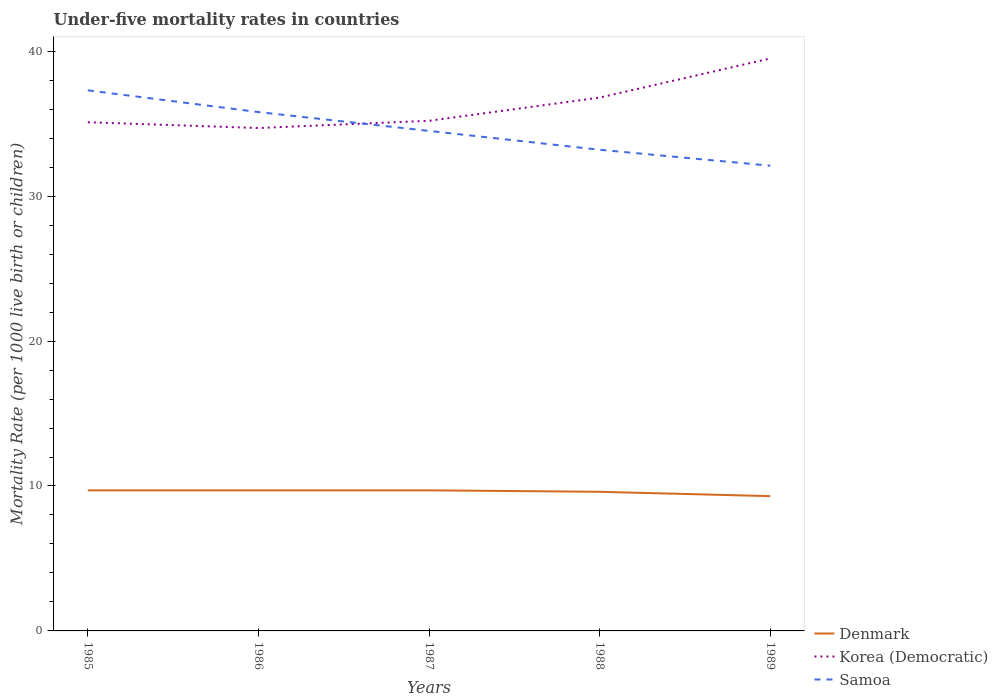Is the number of lines equal to the number of legend labels?
Your answer should be very brief. Yes. Across all years, what is the maximum under-five mortality rate in Samoa?
Offer a very short reply. 32.1. What is the difference between the highest and the second highest under-five mortality rate in Korea (Democratic)?
Make the answer very short. 4.8. How many lines are there?
Provide a succinct answer. 3. How many years are there in the graph?
Provide a short and direct response. 5. What is the difference between two consecutive major ticks on the Y-axis?
Your answer should be compact. 10. Are the values on the major ticks of Y-axis written in scientific E-notation?
Offer a very short reply. No. Does the graph contain grids?
Provide a succinct answer. No. Where does the legend appear in the graph?
Make the answer very short. Bottom right. How many legend labels are there?
Offer a very short reply. 3. What is the title of the graph?
Offer a terse response. Under-five mortality rates in countries. Does "World" appear as one of the legend labels in the graph?
Your answer should be compact. No. What is the label or title of the X-axis?
Offer a very short reply. Years. What is the label or title of the Y-axis?
Offer a very short reply. Mortality Rate (per 1000 live birth or children). What is the Mortality Rate (per 1000 live birth or children) in Denmark in 1985?
Your answer should be compact. 9.7. What is the Mortality Rate (per 1000 live birth or children) in Korea (Democratic) in 1985?
Ensure brevity in your answer.  35.1. What is the Mortality Rate (per 1000 live birth or children) in Samoa in 1985?
Give a very brief answer. 37.3. What is the Mortality Rate (per 1000 live birth or children) of Denmark in 1986?
Offer a terse response. 9.7. What is the Mortality Rate (per 1000 live birth or children) in Korea (Democratic) in 1986?
Ensure brevity in your answer.  34.7. What is the Mortality Rate (per 1000 live birth or children) in Samoa in 1986?
Make the answer very short. 35.8. What is the Mortality Rate (per 1000 live birth or children) in Denmark in 1987?
Give a very brief answer. 9.7. What is the Mortality Rate (per 1000 live birth or children) of Korea (Democratic) in 1987?
Your answer should be compact. 35.2. What is the Mortality Rate (per 1000 live birth or children) in Samoa in 1987?
Your answer should be very brief. 34.5. What is the Mortality Rate (per 1000 live birth or children) in Korea (Democratic) in 1988?
Offer a terse response. 36.8. What is the Mortality Rate (per 1000 live birth or children) of Samoa in 1988?
Keep it short and to the point. 33.2. What is the Mortality Rate (per 1000 live birth or children) in Denmark in 1989?
Your answer should be compact. 9.3. What is the Mortality Rate (per 1000 live birth or children) of Korea (Democratic) in 1989?
Keep it short and to the point. 39.5. What is the Mortality Rate (per 1000 live birth or children) in Samoa in 1989?
Your answer should be very brief. 32.1. Across all years, what is the maximum Mortality Rate (per 1000 live birth or children) in Denmark?
Ensure brevity in your answer.  9.7. Across all years, what is the maximum Mortality Rate (per 1000 live birth or children) in Korea (Democratic)?
Ensure brevity in your answer.  39.5. Across all years, what is the maximum Mortality Rate (per 1000 live birth or children) in Samoa?
Provide a succinct answer. 37.3. Across all years, what is the minimum Mortality Rate (per 1000 live birth or children) of Denmark?
Make the answer very short. 9.3. Across all years, what is the minimum Mortality Rate (per 1000 live birth or children) in Korea (Democratic)?
Provide a short and direct response. 34.7. Across all years, what is the minimum Mortality Rate (per 1000 live birth or children) in Samoa?
Your answer should be very brief. 32.1. What is the total Mortality Rate (per 1000 live birth or children) of Korea (Democratic) in the graph?
Ensure brevity in your answer.  181.3. What is the total Mortality Rate (per 1000 live birth or children) in Samoa in the graph?
Your answer should be compact. 172.9. What is the difference between the Mortality Rate (per 1000 live birth or children) in Samoa in 1985 and that in 1986?
Offer a very short reply. 1.5. What is the difference between the Mortality Rate (per 1000 live birth or children) in Korea (Democratic) in 1985 and that in 1987?
Keep it short and to the point. -0.1. What is the difference between the Mortality Rate (per 1000 live birth or children) of Samoa in 1985 and that in 1987?
Your answer should be very brief. 2.8. What is the difference between the Mortality Rate (per 1000 live birth or children) of Denmark in 1985 and that in 1988?
Keep it short and to the point. 0.1. What is the difference between the Mortality Rate (per 1000 live birth or children) of Korea (Democratic) in 1985 and that in 1988?
Make the answer very short. -1.7. What is the difference between the Mortality Rate (per 1000 live birth or children) of Korea (Democratic) in 1985 and that in 1989?
Keep it short and to the point. -4.4. What is the difference between the Mortality Rate (per 1000 live birth or children) in Denmark in 1986 and that in 1987?
Give a very brief answer. 0. What is the difference between the Mortality Rate (per 1000 live birth or children) of Samoa in 1986 and that in 1987?
Offer a terse response. 1.3. What is the difference between the Mortality Rate (per 1000 live birth or children) of Denmark in 1986 and that in 1988?
Your answer should be very brief. 0.1. What is the difference between the Mortality Rate (per 1000 live birth or children) of Korea (Democratic) in 1986 and that in 1988?
Provide a short and direct response. -2.1. What is the difference between the Mortality Rate (per 1000 live birth or children) in Denmark in 1986 and that in 1989?
Your answer should be very brief. 0.4. What is the difference between the Mortality Rate (per 1000 live birth or children) of Korea (Democratic) in 1986 and that in 1989?
Provide a succinct answer. -4.8. What is the difference between the Mortality Rate (per 1000 live birth or children) in Samoa in 1986 and that in 1989?
Your answer should be very brief. 3.7. What is the difference between the Mortality Rate (per 1000 live birth or children) in Denmark in 1987 and that in 1988?
Offer a very short reply. 0.1. What is the difference between the Mortality Rate (per 1000 live birth or children) in Samoa in 1987 and that in 1988?
Make the answer very short. 1.3. What is the difference between the Mortality Rate (per 1000 live birth or children) in Korea (Democratic) in 1987 and that in 1989?
Keep it short and to the point. -4.3. What is the difference between the Mortality Rate (per 1000 live birth or children) of Denmark in 1988 and that in 1989?
Offer a very short reply. 0.3. What is the difference between the Mortality Rate (per 1000 live birth or children) of Korea (Democratic) in 1988 and that in 1989?
Keep it short and to the point. -2.7. What is the difference between the Mortality Rate (per 1000 live birth or children) in Denmark in 1985 and the Mortality Rate (per 1000 live birth or children) in Samoa in 1986?
Your answer should be compact. -26.1. What is the difference between the Mortality Rate (per 1000 live birth or children) in Korea (Democratic) in 1985 and the Mortality Rate (per 1000 live birth or children) in Samoa in 1986?
Your answer should be compact. -0.7. What is the difference between the Mortality Rate (per 1000 live birth or children) in Denmark in 1985 and the Mortality Rate (per 1000 live birth or children) in Korea (Democratic) in 1987?
Offer a terse response. -25.5. What is the difference between the Mortality Rate (per 1000 live birth or children) of Denmark in 1985 and the Mortality Rate (per 1000 live birth or children) of Samoa in 1987?
Provide a short and direct response. -24.8. What is the difference between the Mortality Rate (per 1000 live birth or children) of Denmark in 1985 and the Mortality Rate (per 1000 live birth or children) of Korea (Democratic) in 1988?
Ensure brevity in your answer.  -27.1. What is the difference between the Mortality Rate (per 1000 live birth or children) in Denmark in 1985 and the Mortality Rate (per 1000 live birth or children) in Samoa in 1988?
Offer a terse response. -23.5. What is the difference between the Mortality Rate (per 1000 live birth or children) of Korea (Democratic) in 1985 and the Mortality Rate (per 1000 live birth or children) of Samoa in 1988?
Your answer should be compact. 1.9. What is the difference between the Mortality Rate (per 1000 live birth or children) of Denmark in 1985 and the Mortality Rate (per 1000 live birth or children) of Korea (Democratic) in 1989?
Provide a succinct answer. -29.8. What is the difference between the Mortality Rate (per 1000 live birth or children) in Denmark in 1985 and the Mortality Rate (per 1000 live birth or children) in Samoa in 1989?
Make the answer very short. -22.4. What is the difference between the Mortality Rate (per 1000 live birth or children) in Korea (Democratic) in 1985 and the Mortality Rate (per 1000 live birth or children) in Samoa in 1989?
Your response must be concise. 3. What is the difference between the Mortality Rate (per 1000 live birth or children) in Denmark in 1986 and the Mortality Rate (per 1000 live birth or children) in Korea (Democratic) in 1987?
Provide a short and direct response. -25.5. What is the difference between the Mortality Rate (per 1000 live birth or children) of Denmark in 1986 and the Mortality Rate (per 1000 live birth or children) of Samoa in 1987?
Offer a very short reply. -24.8. What is the difference between the Mortality Rate (per 1000 live birth or children) of Korea (Democratic) in 1986 and the Mortality Rate (per 1000 live birth or children) of Samoa in 1987?
Keep it short and to the point. 0.2. What is the difference between the Mortality Rate (per 1000 live birth or children) in Denmark in 1986 and the Mortality Rate (per 1000 live birth or children) in Korea (Democratic) in 1988?
Your answer should be very brief. -27.1. What is the difference between the Mortality Rate (per 1000 live birth or children) in Denmark in 1986 and the Mortality Rate (per 1000 live birth or children) in Samoa in 1988?
Ensure brevity in your answer.  -23.5. What is the difference between the Mortality Rate (per 1000 live birth or children) in Denmark in 1986 and the Mortality Rate (per 1000 live birth or children) in Korea (Democratic) in 1989?
Your response must be concise. -29.8. What is the difference between the Mortality Rate (per 1000 live birth or children) in Denmark in 1986 and the Mortality Rate (per 1000 live birth or children) in Samoa in 1989?
Your answer should be compact. -22.4. What is the difference between the Mortality Rate (per 1000 live birth or children) of Denmark in 1987 and the Mortality Rate (per 1000 live birth or children) of Korea (Democratic) in 1988?
Your response must be concise. -27.1. What is the difference between the Mortality Rate (per 1000 live birth or children) of Denmark in 1987 and the Mortality Rate (per 1000 live birth or children) of Samoa in 1988?
Your answer should be compact. -23.5. What is the difference between the Mortality Rate (per 1000 live birth or children) in Korea (Democratic) in 1987 and the Mortality Rate (per 1000 live birth or children) in Samoa in 1988?
Give a very brief answer. 2. What is the difference between the Mortality Rate (per 1000 live birth or children) in Denmark in 1987 and the Mortality Rate (per 1000 live birth or children) in Korea (Democratic) in 1989?
Keep it short and to the point. -29.8. What is the difference between the Mortality Rate (per 1000 live birth or children) of Denmark in 1987 and the Mortality Rate (per 1000 live birth or children) of Samoa in 1989?
Your response must be concise. -22.4. What is the difference between the Mortality Rate (per 1000 live birth or children) of Korea (Democratic) in 1987 and the Mortality Rate (per 1000 live birth or children) of Samoa in 1989?
Keep it short and to the point. 3.1. What is the difference between the Mortality Rate (per 1000 live birth or children) in Denmark in 1988 and the Mortality Rate (per 1000 live birth or children) in Korea (Democratic) in 1989?
Offer a terse response. -29.9. What is the difference between the Mortality Rate (per 1000 live birth or children) in Denmark in 1988 and the Mortality Rate (per 1000 live birth or children) in Samoa in 1989?
Keep it short and to the point. -22.5. What is the average Mortality Rate (per 1000 live birth or children) of Denmark per year?
Offer a very short reply. 9.6. What is the average Mortality Rate (per 1000 live birth or children) in Korea (Democratic) per year?
Keep it short and to the point. 36.26. What is the average Mortality Rate (per 1000 live birth or children) of Samoa per year?
Provide a short and direct response. 34.58. In the year 1985, what is the difference between the Mortality Rate (per 1000 live birth or children) in Denmark and Mortality Rate (per 1000 live birth or children) in Korea (Democratic)?
Give a very brief answer. -25.4. In the year 1985, what is the difference between the Mortality Rate (per 1000 live birth or children) of Denmark and Mortality Rate (per 1000 live birth or children) of Samoa?
Ensure brevity in your answer.  -27.6. In the year 1986, what is the difference between the Mortality Rate (per 1000 live birth or children) of Denmark and Mortality Rate (per 1000 live birth or children) of Korea (Democratic)?
Keep it short and to the point. -25. In the year 1986, what is the difference between the Mortality Rate (per 1000 live birth or children) in Denmark and Mortality Rate (per 1000 live birth or children) in Samoa?
Provide a short and direct response. -26.1. In the year 1986, what is the difference between the Mortality Rate (per 1000 live birth or children) of Korea (Democratic) and Mortality Rate (per 1000 live birth or children) of Samoa?
Give a very brief answer. -1.1. In the year 1987, what is the difference between the Mortality Rate (per 1000 live birth or children) of Denmark and Mortality Rate (per 1000 live birth or children) of Korea (Democratic)?
Make the answer very short. -25.5. In the year 1987, what is the difference between the Mortality Rate (per 1000 live birth or children) of Denmark and Mortality Rate (per 1000 live birth or children) of Samoa?
Offer a very short reply. -24.8. In the year 1987, what is the difference between the Mortality Rate (per 1000 live birth or children) in Korea (Democratic) and Mortality Rate (per 1000 live birth or children) in Samoa?
Offer a terse response. 0.7. In the year 1988, what is the difference between the Mortality Rate (per 1000 live birth or children) of Denmark and Mortality Rate (per 1000 live birth or children) of Korea (Democratic)?
Keep it short and to the point. -27.2. In the year 1988, what is the difference between the Mortality Rate (per 1000 live birth or children) in Denmark and Mortality Rate (per 1000 live birth or children) in Samoa?
Your answer should be very brief. -23.6. In the year 1989, what is the difference between the Mortality Rate (per 1000 live birth or children) in Denmark and Mortality Rate (per 1000 live birth or children) in Korea (Democratic)?
Ensure brevity in your answer.  -30.2. In the year 1989, what is the difference between the Mortality Rate (per 1000 live birth or children) in Denmark and Mortality Rate (per 1000 live birth or children) in Samoa?
Give a very brief answer. -22.8. What is the ratio of the Mortality Rate (per 1000 live birth or children) of Denmark in 1985 to that in 1986?
Make the answer very short. 1. What is the ratio of the Mortality Rate (per 1000 live birth or children) in Korea (Democratic) in 1985 to that in 1986?
Ensure brevity in your answer.  1.01. What is the ratio of the Mortality Rate (per 1000 live birth or children) of Samoa in 1985 to that in 1986?
Your answer should be very brief. 1.04. What is the ratio of the Mortality Rate (per 1000 live birth or children) of Denmark in 1985 to that in 1987?
Your answer should be very brief. 1. What is the ratio of the Mortality Rate (per 1000 live birth or children) in Korea (Democratic) in 1985 to that in 1987?
Your response must be concise. 1. What is the ratio of the Mortality Rate (per 1000 live birth or children) in Samoa in 1985 to that in 1987?
Give a very brief answer. 1.08. What is the ratio of the Mortality Rate (per 1000 live birth or children) in Denmark in 1985 to that in 1988?
Make the answer very short. 1.01. What is the ratio of the Mortality Rate (per 1000 live birth or children) in Korea (Democratic) in 1985 to that in 1988?
Offer a terse response. 0.95. What is the ratio of the Mortality Rate (per 1000 live birth or children) in Samoa in 1985 to that in 1988?
Keep it short and to the point. 1.12. What is the ratio of the Mortality Rate (per 1000 live birth or children) of Denmark in 1985 to that in 1989?
Provide a succinct answer. 1.04. What is the ratio of the Mortality Rate (per 1000 live birth or children) in Korea (Democratic) in 1985 to that in 1989?
Keep it short and to the point. 0.89. What is the ratio of the Mortality Rate (per 1000 live birth or children) of Samoa in 1985 to that in 1989?
Provide a short and direct response. 1.16. What is the ratio of the Mortality Rate (per 1000 live birth or children) of Denmark in 1986 to that in 1987?
Offer a terse response. 1. What is the ratio of the Mortality Rate (per 1000 live birth or children) in Korea (Democratic) in 1986 to that in 1987?
Make the answer very short. 0.99. What is the ratio of the Mortality Rate (per 1000 live birth or children) of Samoa in 1986 to that in 1987?
Make the answer very short. 1.04. What is the ratio of the Mortality Rate (per 1000 live birth or children) of Denmark in 1986 to that in 1988?
Keep it short and to the point. 1.01. What is the ratio of the Mortality Rate (per 1000 live birth or children) in Korea (Democratic) in 1986 to that in 1988?
Give a very brief answer. 0.94. What is the ratio of the Mortality Rate (per 1000 live birth or children) of Samoa in 1986 to that in 1988?
Your response must be concise. 1.08. What is the ratio of the Mortality Rate (per 1000 live birth or children) in Denmark in 1986 to that in 1989?
Your answer should be compact. 1.04. What is the ratio of the Mortality Rate (per 1000 live birth or children) of Korea (Democratic) in 1986 to that in 1989?
Ensure brevity in your answer.  0.88. What is the ratio of the Mortality Rate (per 1000 live birth or children) in Samoa in 1986 to that in 1989?
Your answer should be very brief. 1.12. What is the ratio of the Mortality Rate (per 1000 live birth or children) in Denmark in 1987 to that in 1988?
Provide a short and direct response. 1.01. What is the ratio of the Mortality Rate (per 1000 live birth or children) of Korea (Democratic) in 1987 to that in 1988?
Provide a short and direct response. 0.96. What is the ratio of the Mortality Rate (per 1000 live birth or children) of Samoa in 1987 to that in 1988?
Your answer should be very brief. 1.04. What is the ratio of the Mortality Rate (per 1000 live birth or children) in Denmark in 1987 to that in 1989?
Offer a very short reply. 1.04. What is the ratio of the Mortality Rate (per 1000 live birth or children) of Korea (Democratic) in 1987 to that in 1989?
Provide a short and direct response. 0.89. What is the ratio of the Mortality Rate (per 1000 live birth or children) of Samoa in 1987 to that in 1989?
Your answer should be compact. 1.07. What is the ratio of the Mortality Rate (per 1000 live birth or children) of Denmark in 1988 to that in 1989?
Your answer should be compact. 1.03. What is the ratio of the Mortality Rate (per 1000 live birth or children) of Korea (Democratic) in 1988 to that in 1989?
Ensure brevity in your answer.  0.93. What is the ratio of the Mortality Rate (per 1000 live birth or children) of Samoa in 1988 to that in 1989?
Ensure brevity in your answer.  1.03. What is the difference between the highest and the second highest Mortality Rate (per 1000 live birth or children) in Denmark?
Your answer should be very brief. 0. What is the difference between the highest and the second highest Mortality Rate (per 1000 live birth or children) in Korea (Democratic)?
Offer a terse response. 2.7. What is the difference between the highest and the second highest Mortality Rate (per 1000 live birth or children) in Samoa?
Make the answer very short. 1.5. What is the difference between the highest and the lowest Mortality Rate (per 1000 live birth or children) in Korea (Democratic)?
Make the answer very short. 4.8. What is the difference between the highest and the lowest Mortality Rate (per 1000 live birth or children) in Samoa?
Ensure brevity in your answer.  5.2. 